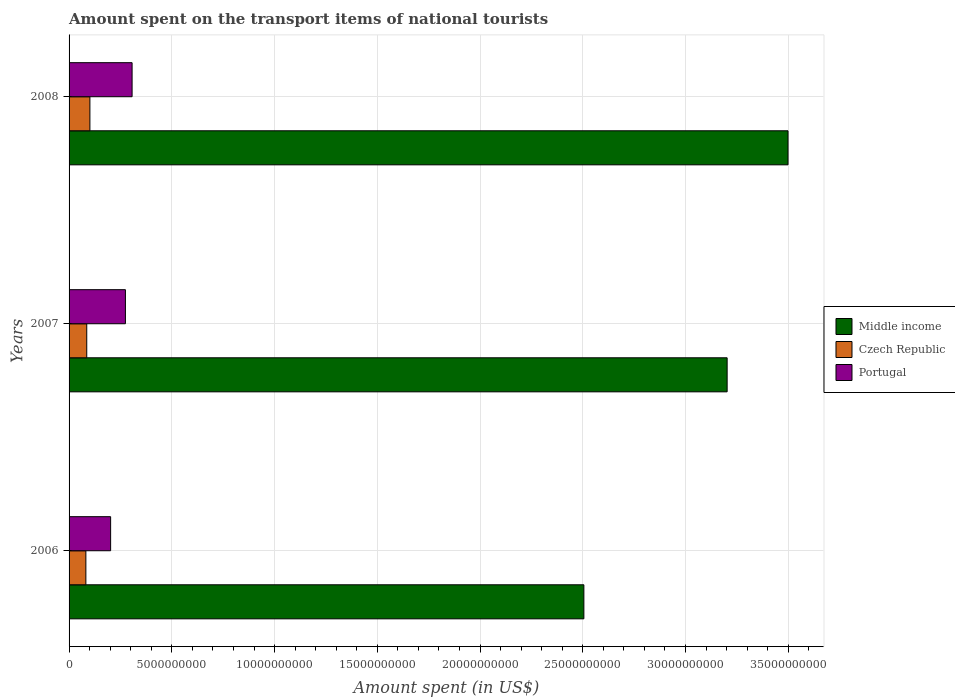How many different coloured bars are there?
Ensure brevity in your answer.  3. How many groups of bars are there?
Offer a terse response. 3. Are the number of bars per tick equal to the number of legend labels?
Offer a terse response. Yes. How many bars are there on the 2nd tick from the top?
Keep it short and to the point. 3. In how many cases, is the number of bars for a given year not equal to the number of legend labels?
Provide a succinct answer. 0. What is the amount spent on the transport items of national tourists in Portugal in 2006?
Offer a very short reply. 2.02e+09. Across all years, what is the maximum amount spent on the transport items of national tourists in Portugal?
Your response must be concise. 3.07e+09. Across all years, what is the minimum amount spent on the transport items of national tourists in Middle income?
Make the answer very short. 2.51e+1. In which year was the amount spent on the transport items of national tourists in Czech Republic maximum?
Your answer should be very brief. 2008. What is the total amount spent on the transport items of national tourists in Middle income in the graph?
Offer a very short reply. 9.21e+1. What is the difference between the amount spent on the transport items of national tourists in Czech Republic in 2006 and that in 2007?
Give a very brief answer. -4.20e+07. What is the difference between the amount spent on the transport items of national tourists in Portugal in 2006 and the amount spent on the transport items of national tourists in Czech Republic in 2008?
Make the answer very short. 1.01e+09. What is the average amount spent on the transport items of national tourists in Portugal per year?
Provide a succinct answer. 2.61e+09. In the year 2007, what is the difference between the amount spent on the transport items of national tourists in Portugal and amount spent on the transport items of national tourists in Czech Republic?
Your response must be concise. 1.88e+09. What is the ratio of the amount spent on the transport items of national tourists in Portugal in 2006 to that in 2007?
Your answer should be compact. 0.74. What is the difference between the highest and the second highest amount spent on the transport items of national tourists in Middle income?
Your response must be concise. 2.96e+09. What is the difference between the highest and the lowest amount spent on the transport items of national tourists in Middle income?
Provide a succinct answer. 9.94e+09. What does the 2nd bar from the bottom in 2006 represents?
Offer a terse response. Czech Republic. Are all the bars in the graph horizontal?
Ensure brevity in your answer.  Yes. How many years are there in the graph?
Your answer should be very brief. 3. Does the graph contain grids?
Provide a short and direct response. Yes. Where does the legend appear in the graph?
Make the answer very short. Center right. How many legend labels are there?
Provide a short and direct response. 3. How are the legend labels stacked?
Ensure brevity in your answer.  Vertical. What is the title of the graph?
Your answer should be very brief. Amount spent on the transport items of national tourists. What is the label or title of the X-axis?
Your response must be concise. Amount spent (in US$). What is the label or title of the Y-axis?
Offer a terse response. Years. What is the Amount spent (in US$) of Middle income in 2006?
Offer a very short reply. 2.51e+1. What is the Amount spent (in US$) of Czech Republic in 2006?
Offer a very short reply. 8.18e+08. What is the Amount spent (in US$) of Portugal in 2006?
Make the answer very short. 2.02e+09. What is the Amount spent (in US$) of Middle income in 2007?
Offer a terse response. 3.20e+1. What is the Amount spent (in US$) of Czech Republic in 2007?
Provide a short and direct response. 8.60e+08. What is the Amount spent (in US$) of Portugal in 2007?
Your response must be concise. 2.74e+09. What is the Amount spent (in US$) of Middle income in 2008?
Keep it short and to the point. 3.50e+1. What is the Amount spent (in US$) in Czech Republic in 2008?
Your response must be concise. 1.01e+09. What is the Amount spent (in US$) in Portugal in 2008?
Make the answer very short. 3.07e+09. Across all years, what is the maximum Amount spent (in US$) in Middle income?
Keep it short and to the point. 3.50e+1. Across all years, what is the maximum Amount spent (in US$) in Czech Republic?
Your answer should be very brief. 1.01e+09. Across all years, what is the maximum Amount spent (in US$) of Portugal?
Your answer should be compact. 3.07e+09. Across all years, what is the minimum Amount spent (in US$) of Middle income?
Offer a terse response. 2.51e+1. Across all years, what is the minimum Amount spent (in US$) in Czech Republic?
Keep it short and to the point. 8.18e+08. Across all years, what is the minimum Amount spent (in US$) in Portugal?
Offer a terse response. 2.02e+09. What is the total Amount spent (in US$) of Middle income in the graph?
Give a very brief answer. 9.21e+1. What is the total Amount spent (in US$) of Czech Republic in the graph?
Offer a very short reply. 2.69e+09. What is the total Amount spent (in US$) in Portugal in the graph?
Make the answer very short. 7.83e+09. What is the difference between the Amount spent (in US$) of Middle income in 2006 and that in 2007?
Offer a terse response. -6.97e+09. What is the difference between the Amount spent (in US$) of Czech Republic in 2006 and that in 2007?
Your response must be concise. -4.20e+07. What is the difference between the Amount spent (in US$) in Portugal in 2006 and that in 2007?
Your answer should be very brief. -7.20e+08. What is the difference between the Amount spent (in US$) in Middle income in 2006 and that in 2008?
Provide a succinct answer. -9.94e+09. What is the difference between the Amount spent (in US$) of Czech Republic in 2006 and that in 2008?
Keep it short and to the point. -1.96e+08. What is the difference between the Amount spent (in US$) in Portugal in 2006 and that in 2008?
Ensure brevity in your answer.  -1.04e+09. What is the difference between the Amount spent (in US$) in Middle income in 2007 and that in 2008?
Provide a short and direct response. -2.96e+09. What is the difference between the Amount spent (in US$) of Czech Republic in 2007 and that in 2008?
Offer a very short reply. -1.54e+08. What is the difference between the Amount spent (in US$) in Portugal in 2007 and that in 2008?
Your answer should be compact. -3.25e+08. What is the difference between the Amount spent (in US$) in Middle income in 2006 and the Amount spent (in US$) in Czech Republic in 2007?
Give a very brief answer. 2.42e+1. What is the difference between the Amount spent (in US$) of Middle income in 2006 and the Amount spent (in US$) of Portugal in 2007?
Your answer should be very brief. 2.23e+1. What is the difference between the Amount spent (in US$) of Czech Republic in 2006 and the Amount spent (in US$) of Portugal in 2007?
Ensure brevity in your answer.  -1.92e+09. What is the difference between the Amount spent (in US$) of Middle income in 2006 and the Amount spent (in US$) of Czech Republic in 2008?
Give a very brief answer. 2.40e+1. What is the difference between the Amount spent (in US$) in Middle income in 2006 and the Amount spent (in US$) in Portugal in 2008?
Your answer should be compact. 2.20e+1. What is the difference between the Amount spent (in US$) in Czech Republic in 2006 and the Amount spent (in US$) in Portugal in 2008?
Ensure brevity in your answer.  -2.25e+09. What is the difference between the Amount spent (in US$) in Middle income in 2007 and the Amount spent (in US$) in Czech Republic in 2008?
Ensure brevity in your answer.  3.10e+1. What is the difference between the Amount spent (in US$) in Middle income in 2007 and the Amount spent (in US$) in Portugal in 2008?
Offer a terse response. 2.90e+1. What is the difference between the Amount spent (in US$) of Czech Republic in 2007 and the Amount spent (in US$) of Portugal in 2008?
Keep it short and to the point. -2.21e+09. What is the average Amount spent (in US$) in Middle income per year?
Provide a succinct answer. 3.07e+1. What is the average Amount spent (in US$) of Czech Republic per year?
Offer a very short reply. 8.97e+08. What is the average Amount spent (in US$) of Portugal per year?
Your answer should be very brief. 2.61e+09. In the year 2006, what is the difference between the Amount spent (in US$) in Middle income and Amount spent (in US$) in Czech Republic?
Offer a very short reply. 2.42e+1. In the year 2006, what is the difference between the Amount spent (in US$) of Middle income and Amount spent (in US$) of Portugal?
Provide a succinct answer. 2.30e+1. In the year 2006, what is the difference between the Amount spent (in US$) in Czech Republic and Amount spent (in US$) in Portugal?
Make the answer very short. -1.20e+09. In the year 2007, what is the difference between the Amount spent (in US$) in Middle income and Amount spent (in US$) in Czech Republic?
Make the answer very short. 3.12e+1. In the year 2007, what is the difference between the Amount spent (in US$) in Middle income and Amount spent (in US$) in Portugal?
Keep it short and to the point. 2.93e+1. In the year 2007, what is the difference between the Amount spent (in US$) of Czech Republic and Amount spent (in US$) of Portugal?
Ensure brevity in your answer.  -1.88e+09. In the year 2008, what is the difference between the Amount spent (in US$) of Middle income and Amount spent (in US$) of Czech Republic?
Offer a terse response. 3.40e+1. In the year 2008, what is the difference between the Amount spent (in US$) in Middle income and Amount spent (in US$) in Portugal?
Keep it short and to the point. 3.19e+1. In the year 2008, what is the difference between the Amount spent (in US$) in Czech Republic and Amount spent (in US$) in Portugal?
Your answer should be very brief. -2.05e+09. What is the ratio of the Amount spent (in US$) of Middle income in 2006 to that in 2007?
Make the answer very short. 0.78. What is the ratio of the Amount spent (in US$) in Czech Republic in 2006 to that in 2007?
Give a very brief answer. 0.95. What is the ratio of the Amount spent (in US$) in Portugal in 2006 to that in 2007?
Your answer should be very brief. 0.74. What is the ratio of the Amount spent (in US$) of Middle income in 2006 to that in 2008?
Keep it short and to the point. 0.72. What is the ratio of the Amount spent (in US$) of Czech Republic in 2006 to that in 2008?
Give a very brief answer. 0.81. What is the ratio of the Amount spent (in US$) in Portugal in 2006 to that in 2008?
Offer a very short reply. 0.66. What is the ratio of the Amount spent (in US$) of Middle income in 2007 to that in 2008?
Give a very brief answer. 0.92. What is the ratio of the Amount spent (in US$) of Czech Republic in 2007 to that in 2008?
Give a very brief answer. 0.85. What is the ratio of the Amount spent (in US$) in Portugal in 2007 to that in 2008?
Provide a short and direct response. 0.89. What is the difference between the highest and the second highest Amount spent (in US$) in Middle income?
Provide a short and direct response. 2.96e+09. What is the difference between the highest and the second highest Amount spent (in US$) in Czech Republic?
Offer a very short reply. 1.54e+08. What is the difference between the highest and the second highest Amount spent (in US$) of Portugal?
Your answer should be very brief. 3.25e+08. What is the difference between the highest and the lowest Amount spent (in US$) in Middle income?
Give a very brief answer. 9.94e+09. What is the difference between the highest and the lowest Amount spent (in US$) in Czech Republic?
Provide a short and direct response. 1.96e+08. What is the difference between the highest and the lowest Amount spent (in US$) in Portugal?
Offer a terse response. 1.04e+09. 